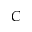Convert formula to latex. <formula><loc_0><loc_0><loc_500><loc_500>C</formula> 